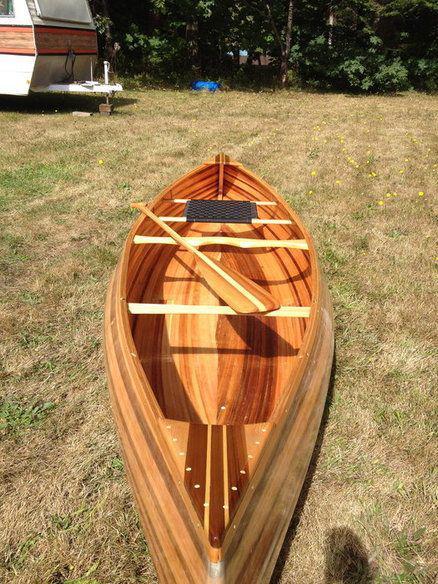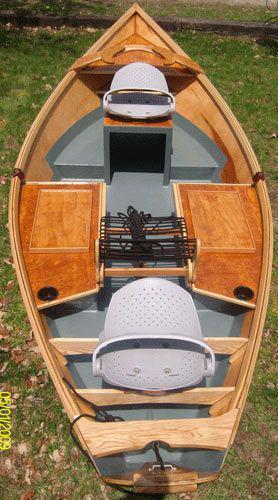The first image is the image on the left, the second image is the image on the right. Examine the images to the left and right. Is the description "There is at least one boat in storage." accurate? Answer yes or no. No. The first image is the image on the left, the second image is the image on the right. For the images displayed, is the sentence "there are two boats in the image pair" factually correct? Answer yes or no. Yes. 